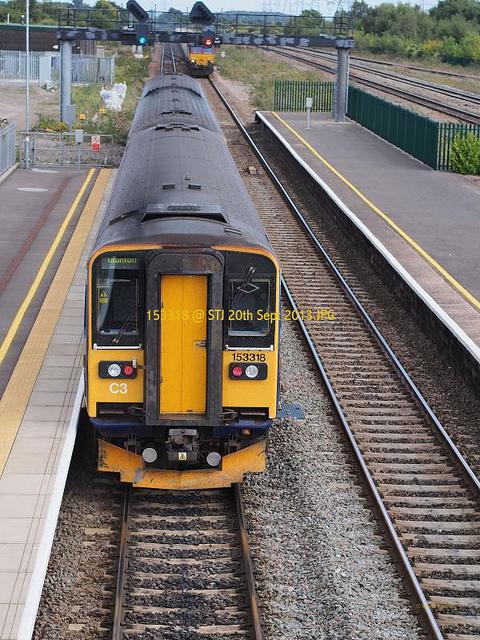What color is the train?
Concise answer only. Yellow. Is the train turning?
Keep it brief. No. What kind of vehicle is this?
Write a very short answer. Train. 